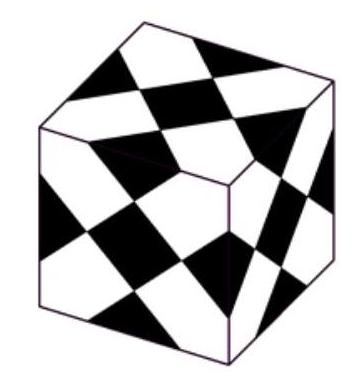Can you explore the mathematical or geometric principles that might be used to create such a pattern? The pattern on the cube utilizes principles of tessellation, symmetry, and probably involves calculations regarding angles and side lengths of triangles and trapezoids used. Each triangle and trapezoid must perfectly meet its neighbors, which suggests the use of congruent shapes or calculated angles ensuring no gaps or overlaps. Such a design can be achieved through methods of geometric construction involving a compass and straightedge, ensuring precise angulations and equal side lengths. 